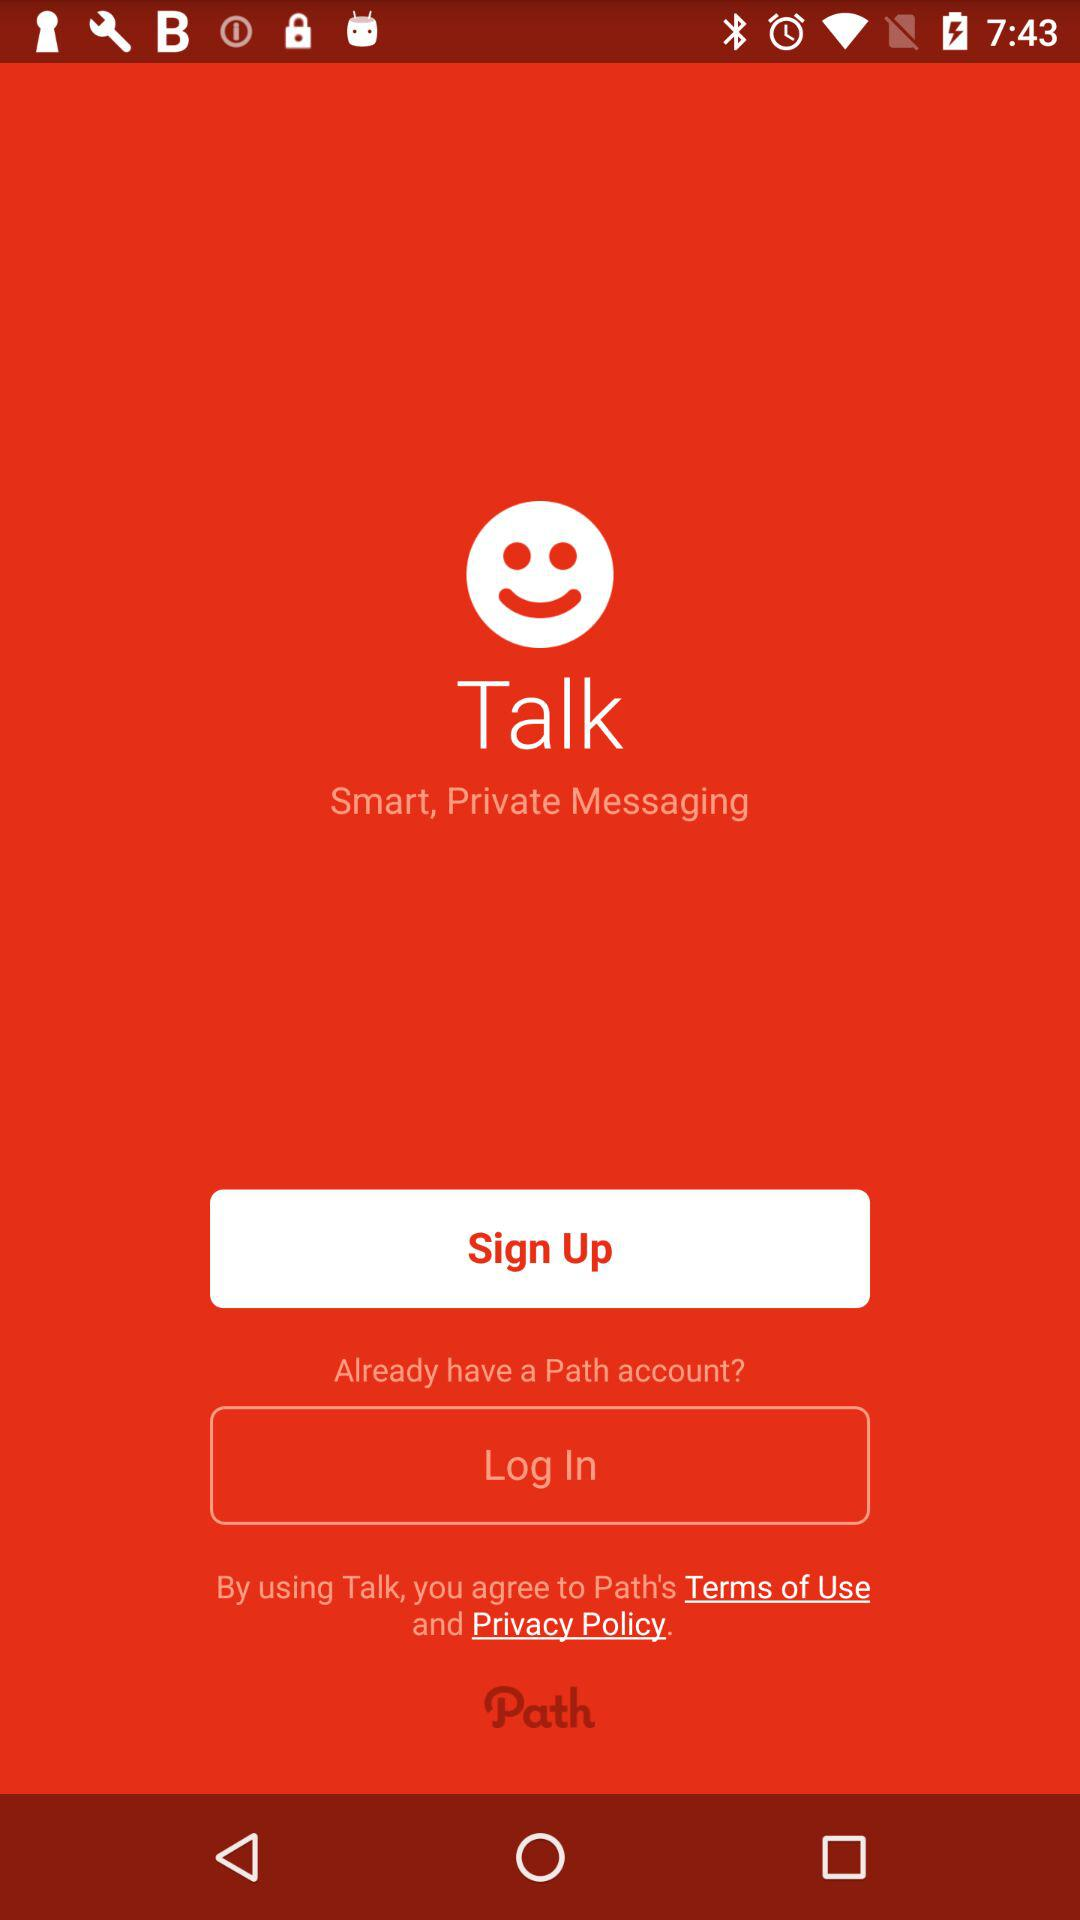What is the application name? The application name is "Path Talk". 